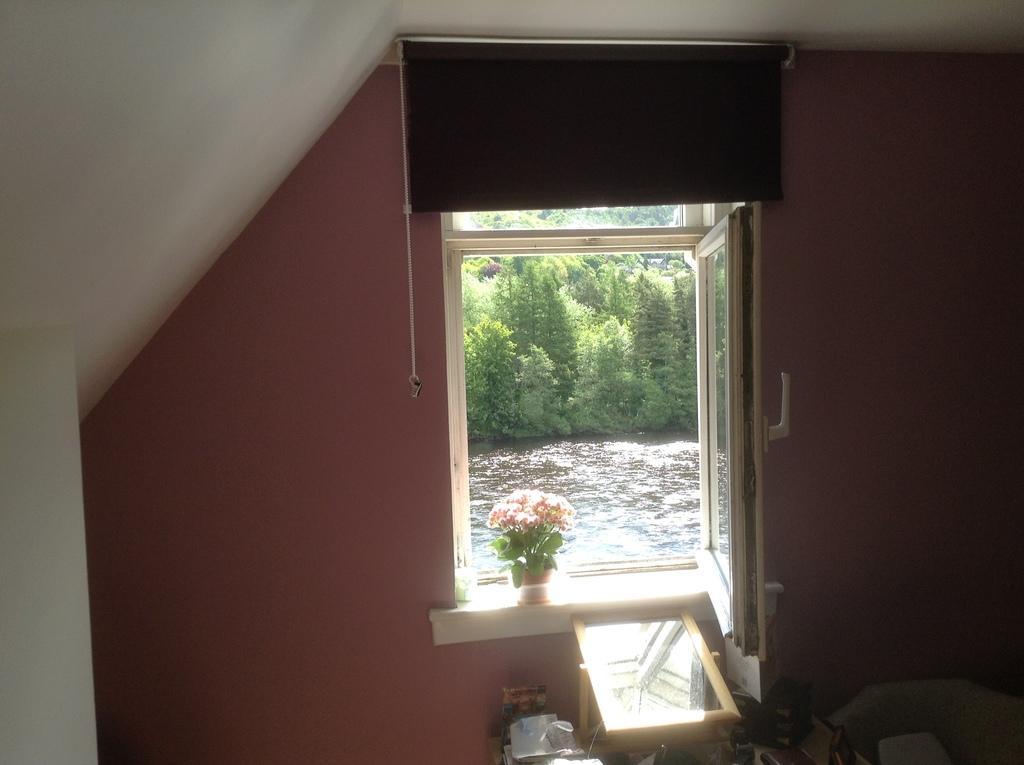Could you give a brief overview of what you see in this image? This is the picture of a room. In this picture there are objects in the foreground and there is a flower vase on the window and there are trees and there is water behind the window. At the top there is a window blind. 